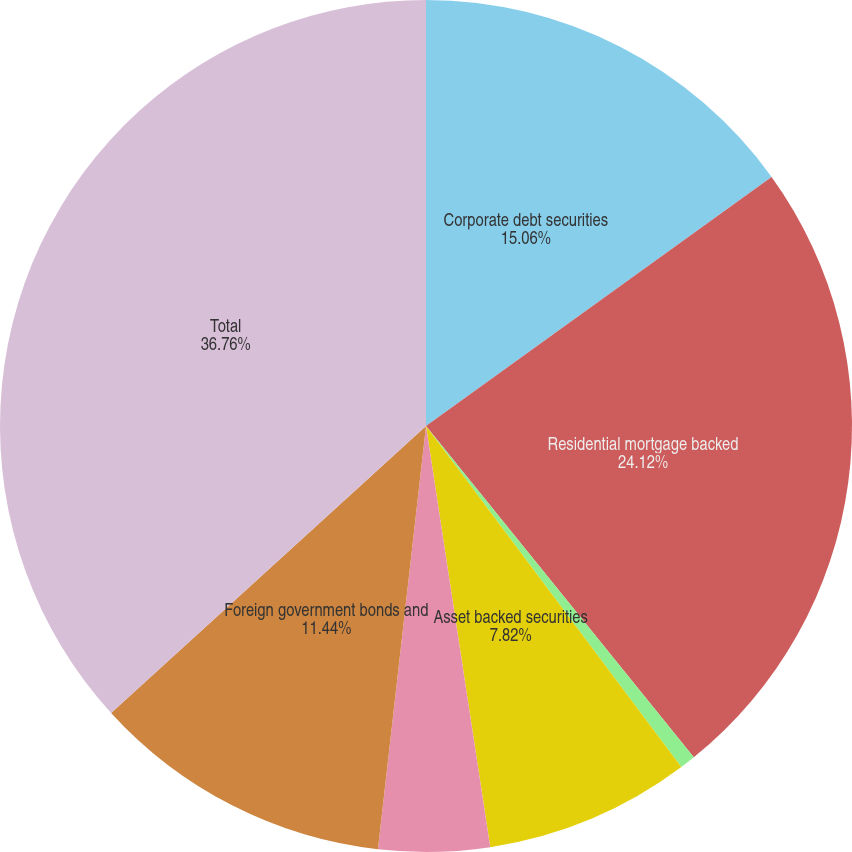Convert chart. <chart><loc_0><loc_0><loc_500><loc_500><pie_chart><fcel>Corporate debt securities<fcel>Residential mortgage backed<fcel>Commercial mortgage backed<fcel>Asset backed securities<fcel>State and municipal<fcel>Foreign government bonds and<fcel>Total<nl><fcel>15.06%<fcel>24.12%<fcel>0.59%<fcel>7.82%<fcel>4.21%<fcel>11.44%<fcel>36.76%<nl></chart> 